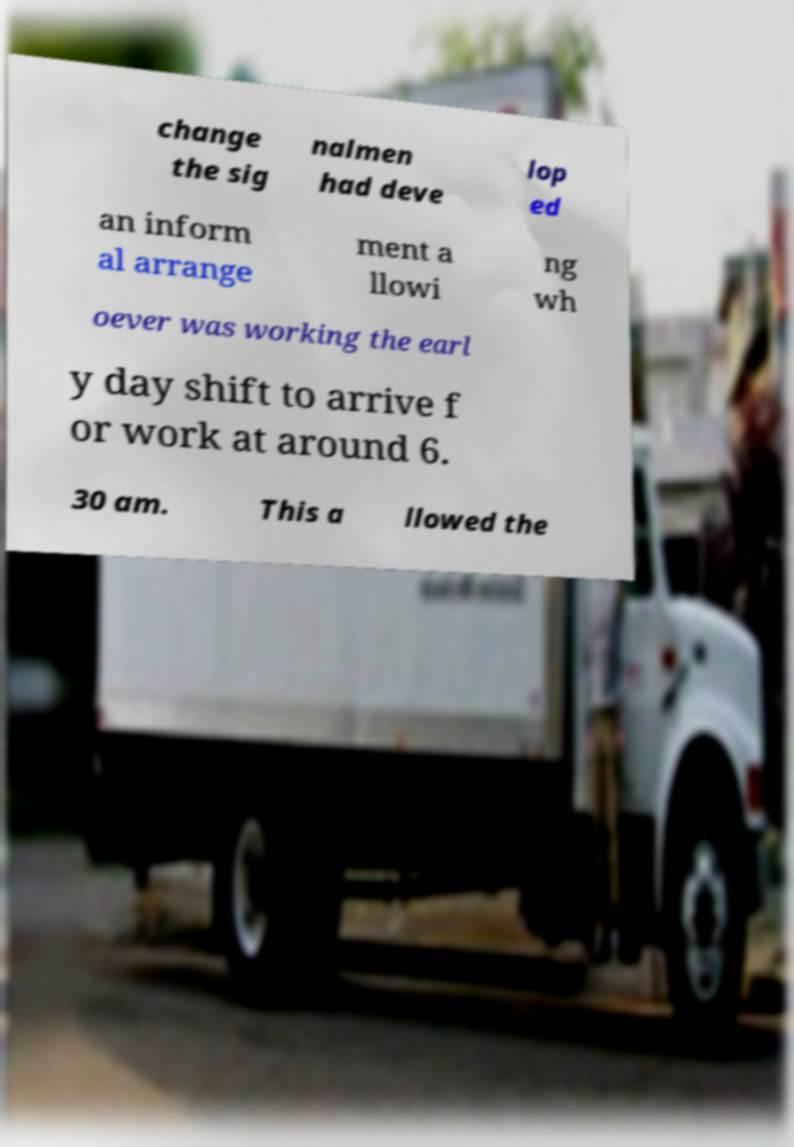Could you extract and type out the text from this image? change the sig nalmen had deve lop ed an inform al arrange ment a llowi ng wh oever was working the earl y day shift to arrive f or work at around 6. 30 am. This a llowed the 